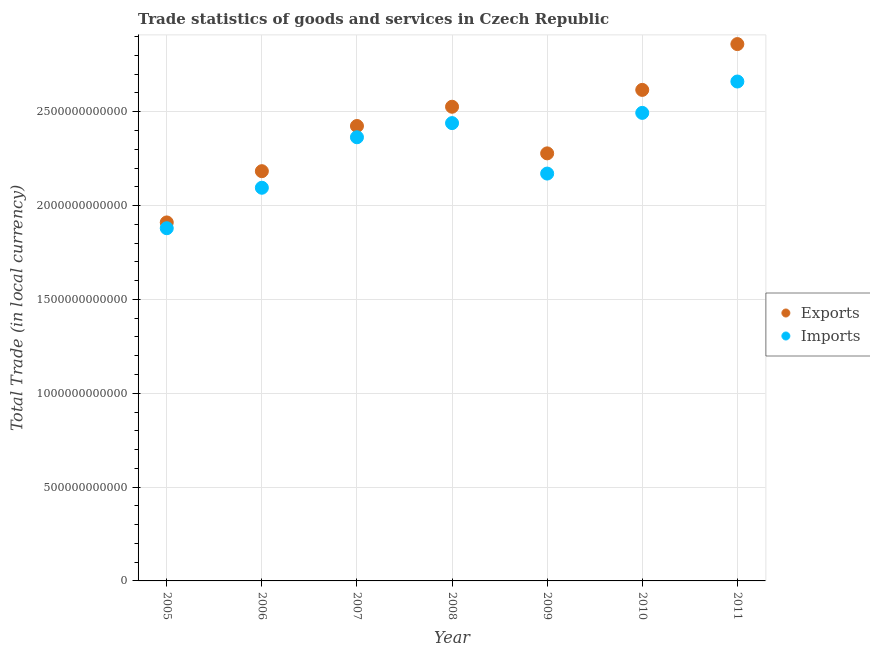How many different coloured dotlines are there?
Your answer should be compact. 2. Is the number of dotlines equal to the number of legend labels?
Ensure brevity in your answer.  Yes. What is the export of goods and services in 2007?
Your response must be concise. 2.42e+12. Across all years, what is the maximum imports of goods and services?
Ensure brevity in your answer.  2.66e+12. Across all years, what is the minimum export of goods and services?
Your response must be concise. 1.91e+12. In which year was the imports of goods and services minimum?
Offer a very short reply. 2005. What is the total export of goods and services in the graph?
Your answer should be compact. 1.68e+13. What is the difference between the imports of goods and services in 2005 and that in 2011?
Offer a terse response. -7.82e+11. What is the difference between the export of goods and services in 2011 and the imports of goods and services in 2007?
Your answer should be compact. 4.96e+11. What is the average imports of goods and services per year?
Offer a terse response. 2.30e+12. In the year 2005, what is the difference between the imports of goods and services and export of goods and services?
Provide a short and direct response. -3.08e+1. What is the ratio of the imports of goods and services in 2009 to that in 2010?
Give a very brief answer. 0.87. Is the export of goods and services in 2005 less than that in 2009?
Provide a short and direct response. Yes. Is the difference between the export of goods and services in 2007 and 2010 greater than the difference between the imports of goods and services in 2007 and 2010?
Your answer should be very brief. No. What is the difference between the highest and the second highest imports of goods and services?
Your response must be concise. 1.67e+11. What is the difference between the highest and the lowest export of goods and services?
Your answer should be compact. 9.50e+11. Is the sum of the imports of goods and services in 2005 and 2009 greater than the maximum export of goods and services across all years?
Provide a short and direct response. Yes. Does the imports of goods and services monotonically increase over the years?
Your response must be concise. No. Is the imports of goods and services strictly less than the export of goods and services over the years?
Offer a very short reply. Yes. How many years are there in the graph?
Offer a very short reply. 7. What is the difference between two consecutive major ticks on the Y-axis?
Your response must be concise. 5.00e+11. Where does the legend appear in the graph?
Provide a succinct answer. Center right. What is the title of the graph?
Keep it short and to the point. Trade statistics of goods and services in Czech Republic. Does "Birth rate" appear as one of the legend labels in the graph?
Give a very brief answer. No. What is the label or title of the Y-axis?
Keep it short and to the point. Total Trade (in local currency). What is the Total Trade (in local currency) of Exports in 2005?
Provide a short and direct response. 1.91e+12. What is the Total Trade (in local currency) of Imports in 2005?
Ensure brevity in your answer.  1.88e+12. What is the Total Trade (in local currency) of Exports in 2006?
Your answer should be compact. 2.18e+12. What is the Total Trade (in local currency) in Imports in 2006?
Offer a very short reply. 2.09e+12. What is the Total Trade (in local currency) in Exports in 2007?
Give a very brief answer. 2.42e+12. What is the Total Trade (in local currency) of Imports in 2007?
Keep it short and to the point. 2.36e+12. What is the Total Trade (in local currency) in Exports in 2008?
Offer a very short reply. 2.53e+12. What is the Total Trade (in local currency) in Imports in 2008?
Provide a succinct answer. 2.44e+12. What is the Total Trade (in local currency) in Exports in 2009?
Ensure brevity in your answer.  2.28e+12. What is the Total Trade (in local currency) of Imports in 2009?
Your answer should be very brief. 2.17e+12. What is the Total Trade (in local currency) in Exports in 2010?
Your response must be concise. 2.62e+12. What is the Total Trade (in local currency) in Imports in 2010?
Provide a short and direct response. 2.49e+12. What is the Total Trade (in local currency) of Exports in 2011?
Your answer should be compact. 2.86e+12. What is the Total Trade (in local currency) in Imports in 2011?
Make the answer very short. 2.66e+12. Across all years, what is the maximum Total Trade (in local currency) of Exports?
Your response must be concise. 2.86e+12. Across all years, what is the maximum Total Trade (in local currency) of Imports?
Your answer should be very brief. 2.66e+12. Across all years, what is the minimum Total Trade (in local currency) in Exports?
Your response must be concise. 1.91e+12. Across all years, what is the minimum Total Trade (in local currency) of Imports?
Provide a succinct answer. 1.88e+12. What is the total Total Trade (in local currency) of Exports in the graph?
Your answer should be very brief. 1.68e+13. What is the total Total Trade (in local currency) in Imports in the graph?
Offer a very short reply. 1.61e+13. What is the difference between the Total Trade (in local currency) of Exports in 2005 and that in 2006?
Give a very brief answer. -2.73e+11. What is the difference between the Total Trade (in local currency) in Imports in 2005 and that in 2006?
Your response must be concise. -2.16e+11. What is the difference between the Total Trade (in local currency) of Exports in 2005 and that in 2007?
Ensure brevity in your answer.  -5.14e+11. What is the difference between the Total Trade (in local currency) of Imports in 2005 and that in 2007?
Your answer should be compact. -4.85e+11. What is the difference between the Total Trade (in local currency) of Exports in 2005 and that in 2008?
Provide a short and direct response. -6.16e+11. What is the difference between the Total Trade (in local currency) in Imports in 2005 and that in 2008?
Your response must be concise. -5.60e+11. What is the difference between the Total Trade (in local currency) in Exports in 2005 and that in 2009?
Offer a very short reply. -3.68e+11. What is the difference between the Total Trade (in local currency) in Imports in 2005 and that in 2009?
Keep it short and to the point. -2.91e+11. What is the difference between the Total Trade (in local currency) of Exports in 2005 and that in 2010?
Your answer should be compact. -7.06e+11. What is the difference between the Total Trade (in local currency) in Imports in 2005 and that in 2010?
Your response must be concise. -6.15e+11. What is the difference between the Total Trade (in local currency) of Exports in 2005 and that in 2011?
Your answer should be compact. -9.50e+11. What is the difference between the Total Trade (in local currency) in Imports in 2005 and that in 2011?
Ensure brevity in your answer.  -7.82e+11. What is the difference between the Total Trade (in local currency) in Exports in 2006 and that in 2007?
Your answer should be very brief. -2.41e+11. What is the difference between the Total Trade (in local currency) of Imports in 2006 and that in 2007?
Keep it short and to the point. -2.69e+11. What is the difference between the Total Trade (in local currency) of Exports in 2006 and that in 2008?
Your answer should be very brief. -3.43e+11. What is the difference between the Total Trade (in local currency) of Imports in 2006 and that in 2008?
Your answer should be very brief. -3.44e+11. What is the difference between the Total Trade (in local currency) of Exports in 2006 and that in 2009?
Ensure brevity in your answer.  -9.49e+1. What is the difference between the Total Trade (in local currency) in Imports in 2006 and that in 2009?
Keep it short and to the point. -7.56e+1. What is the difference between the Total Trade (in local currency) in Exports in 2006 and that in 2010?
Ensure brevity in your answer.  -4.33e+11. What is the difference between the Total Trade (in local currency) of Imports in 2006 and that in 2010?
Your response must be concise. -3.99e+11. What is the difference between the Total Trade (in local currency) in Exports in 2006 and that in 2011?
Provide a succinct answer. -6.77e+11. What is the difference between the Total Trade (in local currency) of Imports in 2006 and that in 2011?
Your answer should be very brief. -5.66e+11. What is the difference between the Total Trade (in local currency) of Exports in 2007 and that in 2008?
Offer a very short reply. -1.03e+11. What is the difference between the Total Trade (in local currency) in Imports in 2007 and that in 2008?
Keep it short and to the point. -7.54e+1. What is the difference between the Total Trade (in local currency) of Exports in 2007 and that in 2009?
Ensure brevity in your answer.  1.46e+11. What is the difference between the Total Trade (in local currency) in Imports in 2007 and that in 2009?
Ensure brevity in your answer.  1.94e+11. What is the difference between the Total Trade (in local currency) in Exports in 2007 and that in 2010?
Give a very brief answer. -1.92e+11. What is the difference between the Total Trade (in local currency) of Imports in 2007 and that in 2010?
Your answer should be compact. -1.30e+11. What is the difference between the Total Trade (in local currency) in Exports in 2007 and that in 2011?
Give a very brief answer. -4.36e+11. What is the difference between the Total Trade (in local currency) of Imports in 2007 and that in 2011?
Provide a short and direct response. -2.97e+11. What is the difference between the Total Trade (in local currency) in Exports in 2008 and that in 2009?
Give a very brief answer. 2.48e+11. What is the difference between the Total Trade (in local currency) in Imports in 2008 and that in 2009?
Offer a very short reply. 2.69e+11. What is the difference between the Total Trade (in local currency) in Exports in 2008 and that in 2010?
Ensure brevity in your answer.  -8.98e+1. What is the difference between the Total Trade (in local currency) of Imports in 2008 and that in 2010?
Provide a succinct answer. -5.45e+1. What is the difference between the Total Trade (in local currency) in Exports in 2008 and that in 2011?
Offer a very short reply. -3.34e+11. What is the difference between the Total Trade (in local currency) of Imports in 2008 and that in 2011?
Make the answer very short. -2.22e+11. What is the difference between the Total Trade (in local currency) of Exports in 2009 and that in 2010?
Make the answer very short. -3.38e+11. What is the difference between the Total Trade (in local currency) in Imports in 2009 and that in 2010?
Ensure brevity in your answer.  -3.23e+11. What is the difference between the Total Trade (in local currency) of Exports in 2009 and that in 2011?
Your answer should be very brief. -5.82e+11. What is the difference between the Total Trade (in local currency) in Imports in 2009 and that in 2011?
Your answer should be very brief. -4.90e+11. What is the difference between the Total Trade (in local currency) of Exports in 2010 and that in 2011?
Offer a terse response. -2.44e+11. What is the difference between the Total Trade (in local currency) of Imports in 2010 and that in 2011?
Keep it short and to the point. -1.67e+11. What is the difference between the Total Trade (in local currency) in Exports in 2005 and the Total Trade (in local currency) in Imports in 2006?
Your answer should be very brief. -1.85e+11. What is the difference between the Total Trade (in local currency) in Exports in 2005 and the Total Trade (in local currency) in Imports in 2007?
Your response must be concise. -4.54e+11. What is the difference between the Total Trade (in local currency) in Exports in 2005 and the Total Trade (in local currency) in Imports in 2008?
Offer a terse response. -5.29e+11. What is the difference between the Total Trade (in local currency) in Exports in 2005 and the Total Trade (in local currency) in Imports in 2009?
Your answer should be compact. -2.60e+11. What is the difference between the Total Trade (in local currency) of Exports in 2005 and the Total Trade (in local currency) of Imports in 2010?
Give a very brief answer. -5.84e+11. What is the difference between the Total Trade (in local currency) of Exports in 2005 and the Total Trade (in local currency) of Imports in 2011?
Provide a short and direct response. -7.51e+11. What is the difference between the Total Trade (in local currency) in Exports in 2006 and the Total Trade (in local currency) in Imports in 2007?
Your answer should be very brief. -1.81e+11. What is the difference between the Total Trade (in local currency) of Exports in 2006 and the Total Trade (in local currency) of Imports in 2008?
Provide a succinct answer. -2.56e+11. What is the difference between the Total Trade (in local currency) in Exports in 2006 and the Total Trade (in local currency) in Imports in 2009?
Offer a terse response. 1.28e+1. What is the difference between the Total Trade (in local currency) in Exports in 2006 and the Total Trade (in local currency) in Imports in 2010?
Offer a very short reply. -3.11e+11. What is the difference between the Total Trade (in local currency) of Exports in 2006 and the Total Trade (in local currency) of Imports in 2011?
Offer a very short reply. -4.78e+11. What is the difference between the Total Trade (in local currency) of Exports in 2007 and the Total Trade (in local currency) of Imports in 2008?
Your response must be concise. -1.54e+1. What is the difference between the Total Trade (in local currency) of Exports in 2007 and the Total Trade (in local currency) of Imports in 2009?
Your response must be concise. 2.54e+11. What is the difference between the Total Trade (in local currency) of Exports in 2007 and the Total Trade (in local currency) of Imports in 2010?
Your answer should be compact. -6.99e+1. What is the difference between the Total Trade (in local currency) of Exports in 2007 and the Total Trade (in local currency) of Imports in 2011?
Ensure brevity in your answer.  -2.37e+11. What is the difference between the Total Trade (in local currency) of Exports in 2008 and the Total Trade (in local currency) of Imports in 2009?
Offer a very short reply. 3.56e+11. What is the difference between the Total Trade (in local currency) in Exports in 2008 and the Total Trade (in local currency) in Imports in 2010?
Your response must be concise. 3.27e+1. What is the difference between the Total Trade (in local currency) of Exports in 2008 and the Total Trade (in local currency) of Imports in 2011?
Keep it short and to the point. -1.34e+11. What is the difference between the Total Trade (in local currency) of Exports in 2009 and the Total Trade (in local currency) of Imports in 2010?
Ensure brevity in your answer.  -2.16e+11. What is the difference between the Total Trade (in local currency) of Exports in 2009 and the Total Trade (in local currency) of Imports in 2011?
Your answer should be very brief. -3.83e+11. What is the difference between the Total Trade (in local currency) of Exports in 2010 and the Total Trade (in local currency) of Imports in 2011?
Ensure brevity in your answer.  -4.46e+1. What is the average Total Trade (in local currency) in Exports per year?
Your response must be concise. 2.40e+12. What is the average Total Trade (in local currency) in Imports per year?
Your response must be concise. 2.30e+12. In the year 2005, what is the difference between the Total Trade (in local currency) of Exports and Total Trade (in local currency) of Imports?
Give a very brief answer. 3.08e+1. In the year 2006, what is the difference between the Total Trade (in local currency) in Exports and Total Trade (in local currency) in Imports?
Provide a short and direct response. 8.83e+1. In the year 2007, what is the difference between the Total Trade (in local currency) in Exports and Total Trade (in local currency) in Imports?
Offer a terse response. 6.00e+1. In the year 2008, what is the difference between the Total Trade (in local currency) of Exports and Total Trade (in local currency) of Imports?
Offer a very short reply. 8.72e+1. In the year 2009, what is the difference between the Total Trade (in local currency) of Exports and Total Trade (in local currency) of Imports?
Offer a terse response. 1.08e+11. In the year 2010, what is the difference between the Total Trade (in local currency) of Exports and Total Trade (in local currency) of Imports?
Give a very brief answer. 1.23e+11. In the year 2011, what is the difference between the Total Trade (in local currency) in Exports and Total Trade (in local currency) in Imports?
Provide a short and direct response. 1.99e+11. What is the ratio of the Total Trade (in local currency) of Exports in 2005 to that in 2006?
Your response must be concise. 0.87. What is the ratio of the Total Trade (in local currency) in Imports in 2005 to that in 2006?
Offer a very short reply. 0.9. What is the ratio of the Total Trade (in local currency) in Exports in 2005 to that in 2007?
Keep it short and to the point. 0.79. What is the ratio of the Total Trade (in local currency) of Imports in 2005 to that in 2007?
Your answer should be compact. 0.8. What is the ratio of the Total Trade (in local currency) of Exports in 2005 to that in 2008?
Your answer should be compact. 0.76. What is the ratio of the Total Trade (in local currency) in Imports in 2005 to that in 2008?
Give a very brief answer. 0.77. What is the ratio of the Total Trade (in local currency) in Exports in 2005 to that in 2009?
Ensure brevity in your answer.  0.84. What is the ratio of the Total Trade (in local currency) of Imports in 2005 to that in 2009?
Your answer should be compact. 0.87. What is the ratio of the Total Trade (in local currency) in Exports in 2005 to that in 2010?
Give a very brief answer. 0.73. What is the ratio of the Total Trade (in local currency) in Imports in 2005 to that in 2010?
Make the answer very short. 0.75. What is the ratio of the Total Trade (in local currency) in Exports in 2005 to that in 2011?
Your answer should be very brief. 0.67. What is the ratio of the Total Trade (in local currency) in Imports in 2005 to that in 2011?
Your answer should be compact. 0.71. What is the ratio of the Total Trade (in local currency) in Exports in 2006 to that in 2007?
Provide a short and direct response. 0.9. What is the ratio of the Total Trade (in local currency) of Imports in 2006 to that in 2007?
Provide a succinct answer. 0.89. What is the ratio of the Total Trade (in local currency) in Exports in 2006 to that in 2008?
Provide a succinct answer. 0.86. What is the ratio of the Total Trade (in local currency) of Imports in 2006 to that in 2008?
Provide a succinct answer. 0.86. What is the ratio of the Total Trade (in local currency) in Exports in 2006 to that in 2009?
Give a very brief answer. 0.96. What is the ratio of the Total Trade (in local currency) of Imports in 2006 to that in 2009?
Give a very brief answer. 0.97. What is the ratio of the Total Trade (in local currency) in Exports in 2006 to that in 2010?
Your response must be concise. 0.83. What is the ratio of the Total Trade (in local currency) of Imports in 2006 to that in 2010?
Offer a terse response. 0.84. What is the ratio of the Total Trade (in local currency) in Exports in 2006 to that in 2011?
Provide a short and direct response. 0.76. What is the ratio of the Total Trade (in local currency) in Imports in 2006 to that in 2011?
Your answer should be compact. 0.79. What is the ratio of the Total Trade (in local currency) in Exports in 2007 to that in 2008?
Keep it short and to the point. 0.96. What is the ratio of the Total Trade (in local currency) in Imports in 2007 to that in 2008?
Ensure brevity in your answer.  0.97. What is the ratio of the Total Trade (in local currency) of Exports in 2007 to that in 2009?
Provide a short and direct response. 1.06. What is the ratio of the Total Trade (in local currency) of Imports in 2007 to that in 2009?
Give a very brief answer. 1.09. What is the ratio of the Total Trade (in local currency) of Exports in 2007 to that in 2010?
Your answer should be compact. 0.93. What is the ratio of the Total Trade (in local currency) of Imports in 2007 to that in 2010?
Your answer should be very brief. 0.95. What is the ratio of the Total Trade (in local currency) of Exports in 2007 to that in 2011?
Your answer should be compact. 0.85. What is the ratio of the Total Trade (in local currency) in Imports in 2007 to that in 2011?
Keep it short and to the point. 0.89. What is the ratio of the Total Trade (in local currency) of Exports in 2008 to that in 2009?
Your answer should be compact. 1.11. What is the ratio of the Total Trade (in local currency) in Imports in 2008 to that in 2009?
Your answer should be compact. 1.12. What is the ratio of the Total Trade (in local currency) of Exports in 2008 to that in 2010?
Ensure brevity in your answer.  0.97. What is the ratio of the Total Trade (in local currency) in Imports in 2008 to that in 2010?
Your response must be concise. 0.98. What is the ratio of the Total Trade (in local currency) of Exports in 2008 to that in 2011?
Offer a very short reply. 0.88. What is the ratio of the Total Trade (in local currency) in Exports in 2009 to that in 2010?
Give a very brief answer. 0.87. What is the ratio of the Total Trade (in local currency) in Imports in 2009 to that in 2010?
Offer a very short reply. 0.87. What is the ratio of the Total Trade (in local currency) of Exports in 2009 to that in 2011?
Keep it short and to the point. 0.8. What is the ratio of the Total Trade (in local currency) of Imports in 2009 to that in 2011?
Make the answer very short. 0.82. What is the ratio of the Total Trade (in local currency) in Exports in 2010 to that in 2011?
Your answer should be compact. 0.91. What is the ratio of the Total Trade (in local currency) in Imports in 2010 to that in 2011?
Offer a terse response. 0.94. What is the difference between the highest and the second highest Total Trade (in local currency) in Exports?
Your answer should be compact. 2.44e+11. What is the difference between the highest and the second highest Total Trade (in local currency) in Imports?
Make the answer very short. 1.67e+11. What is the difference between the highest and the lowest Total Trade (in local currency) in Exports?
Your response must be concise. 9.50e+11. What is the difference between the highest and the lowest Total Trade (in local currency) of Imports?
Offer a terse response. 7.82e+11. 